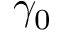<formula> <loc_0><loc_0><loc_500><loc_500>\gamma _ { 0 }</formula> 